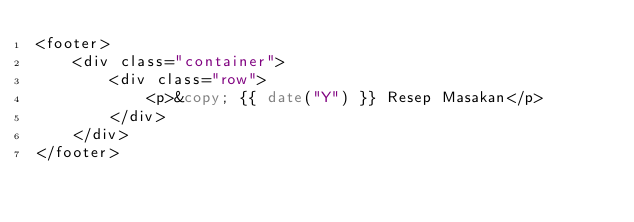Convert code to text. <code><loc_0><loc_0><loc_500><loc_500><_PHP_><footer>
    <div class="container">
        <div class="row">
            <p>&copy; {{ date("Y") }} Resep Masakan</p>
        </div>
    </div>
</footer>
</code> 